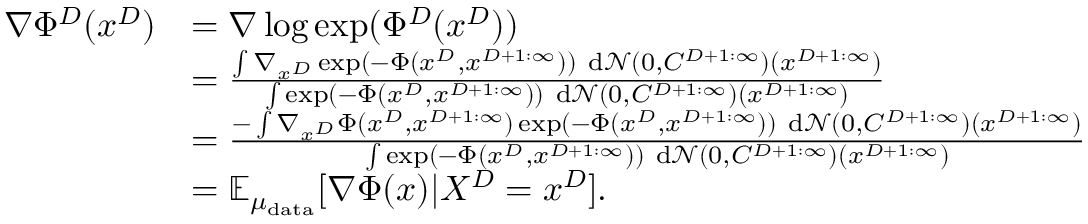<formula> <loc_0><loc_0><loc_500><loc_500>\begin{array} { r l } { \nabla \Phi ^ { D } ( x ^ { D } ) } & { = \nabla \log \exp ( \Phi ^ { D } ( x ^ { D } ) ) } \\ & { = \frac { \int \nabla _ { x ^ { D } } \exp ( - \Phi ( x ^ { D } , x ^ { D + 1 \colon \infty } ) ) d \mathcal { N } ( 0 , C ^ { D + 1 \colon \infty } ) ( x ^ { D + 1 \colon \infty } ) } { \int \exp ( - \Phi ( x ^ { D } , x ^ { D + 1 \colon \infty } ) ) d \mathcal { N } ( 0 , C ^ { D + 1 \colon \infty } ) ( x ^ { D + 1 \colon \infty } ) } } \\ & { = \frac { - \int \nabla _ { x ^ { D } } \Phi ( x ^ { D } , x ^ { D + 1 \colon \infty } ) \exp ( - \Phi ( x ^ { D } , x ^ { D + 1 \colon \infty } ) ) d \mathcal { N } ( 0 , C ^ { D + 1 \colon \infty } ) ( x ^ { D + 1 \colon \infty } ) } { \int \exp ( - \Phi ( x ^ { D } , x ^ { D + 1 \colon \infty } ) ) d \mathcal { N } ( 0 , C ^ { D + 1 \colon \infty } ) ( x ^ { D + 1 \colon \infty } ) } } \\ & { = \mathbb { E } _ { \mu _ { d a t a } } [ \nabla \Phi ( x ) | X ^ { D } = x ^ { D } ] . } \end{array}</formula> 